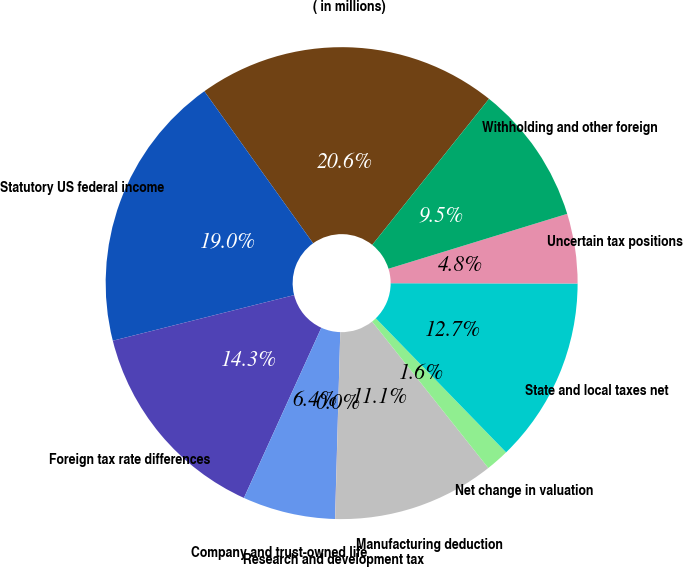Convert chart. <chart><loc_0><loc_0><loc_500><loc_500><pie_chart><fcel>( in millions)<fcel>Statutory US federal income<fcel>Foreign tax rate differences<fcel>Company and trust-owned life<fcel>Research and development tax<fcel>Manufacturing deduction<fcel>Net change in valuation<fcel>State and local taxes net<fcel>Uncertain tax positions<fcel>Withholding and other foreign<nl><fcel>20.62%<fcel>19.04%<fcel>14.28%<fcel>6.35%<fcel>0.01%<fcel>11.11%<fcel>1.6%<fcel>12.7%<fcel>4.77%<fcel>9.52%<nl></chart> 